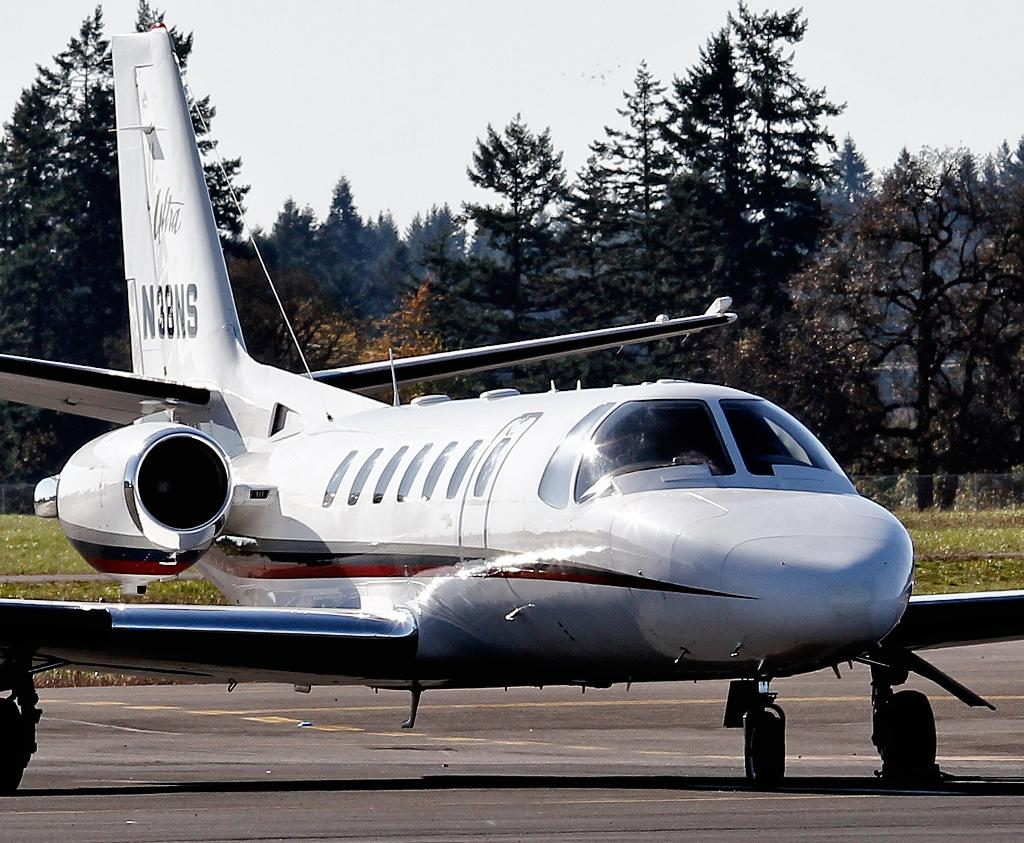<image>
Create a compact narrative representing the image presented. a plane parked with the word Ultra written on the tail 